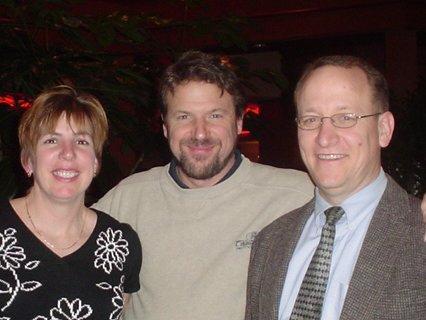How many people are there?
Give a very brief answer. 3. 